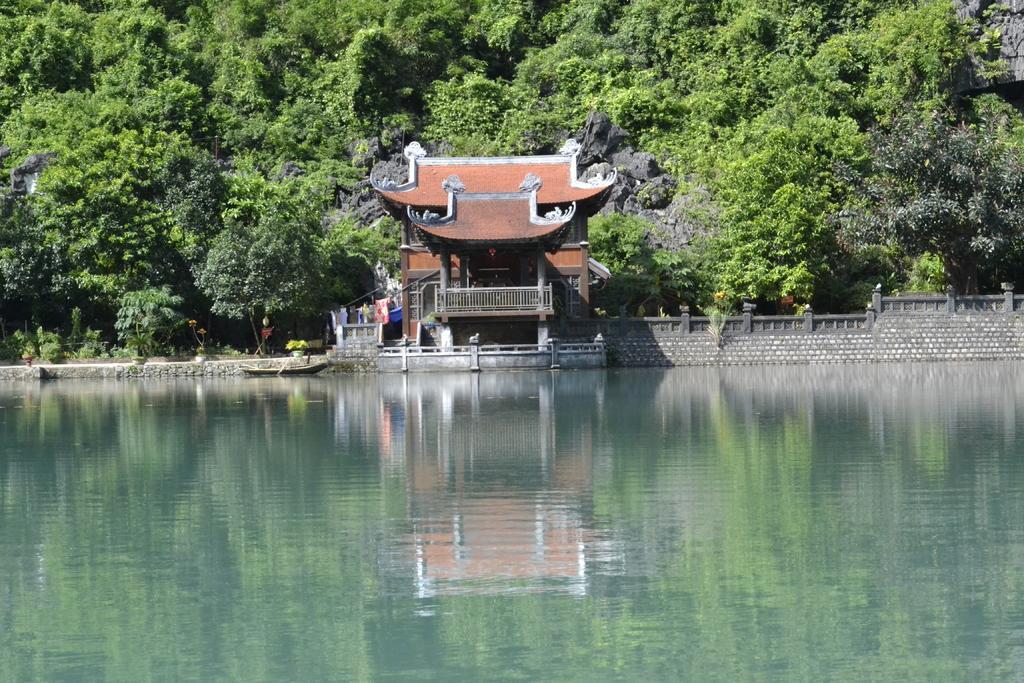How would you summarize this image in a sentence or two? In this image we can see water here, this is the building even we can see the reflection of the building in the water. And on the background there are many trees. And here this is the wall. 